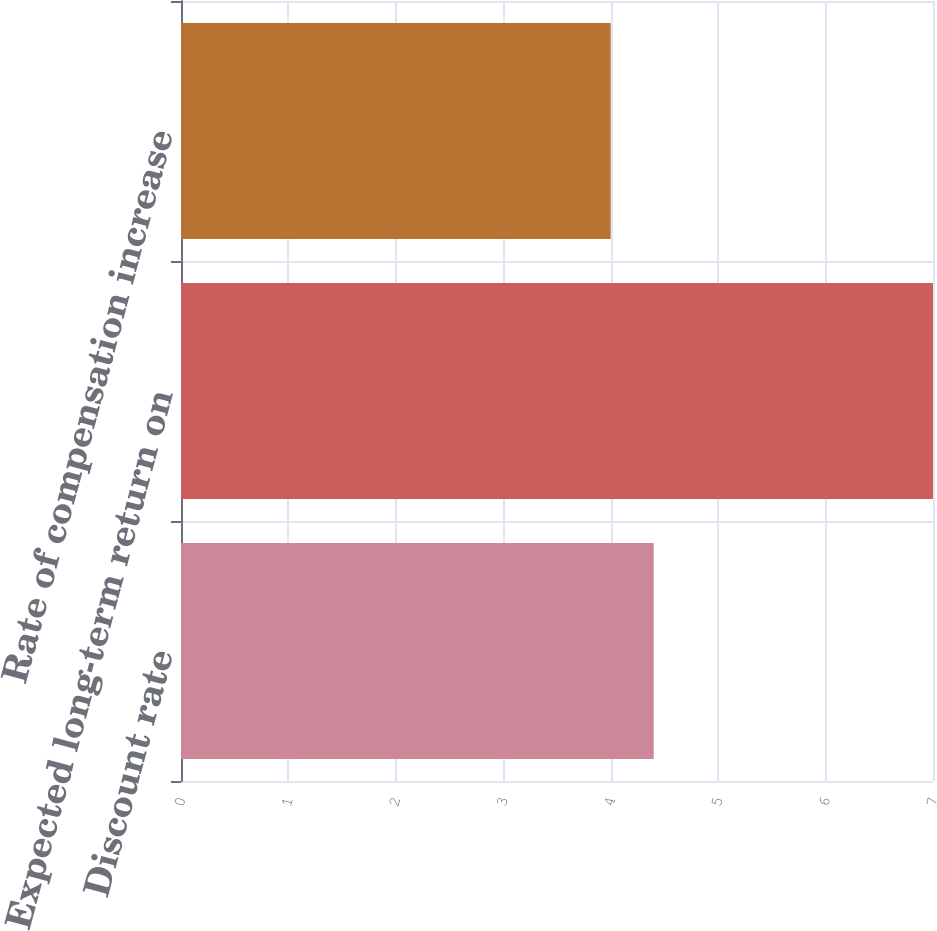<chart> <loc_0><loc_0><loc_500><loc_500><bar_chart><fcel>Discount rate<fcel>Expected long-term return on<fcel>Rate of compensation increase<nl><fcel>4.4<fcel>7<fcel>4<nl></chart> 